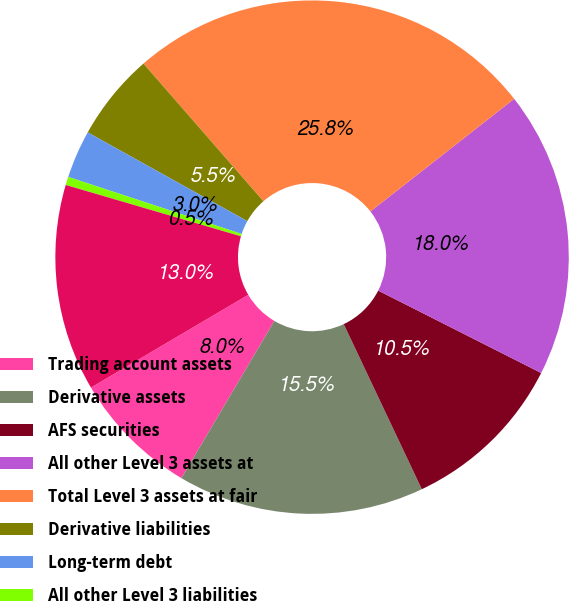Convert chart. <chart><loc_0><loc_0><loc_500><loc_500><pie_chart><fcel>Trading account assets<fcel>Derivative assets<fcel>AFS securities<fcel>All other Level 3 assets at<fcel>Total Level 3 assets at fair<fcel>Derivative liabilities<fcel>Long-term debt<fcel>All other Level 3 liabilities<fcel>Total Level 3 liabilities at<nl><fcel>8.02%<fcel>15.53%<fcel>10.52%<fcel>18.03%<fcel>25.83%<fcel>5.52%<fcel>3.02%<fcel>0.52%<fcel>13.02%<nl></chart> 